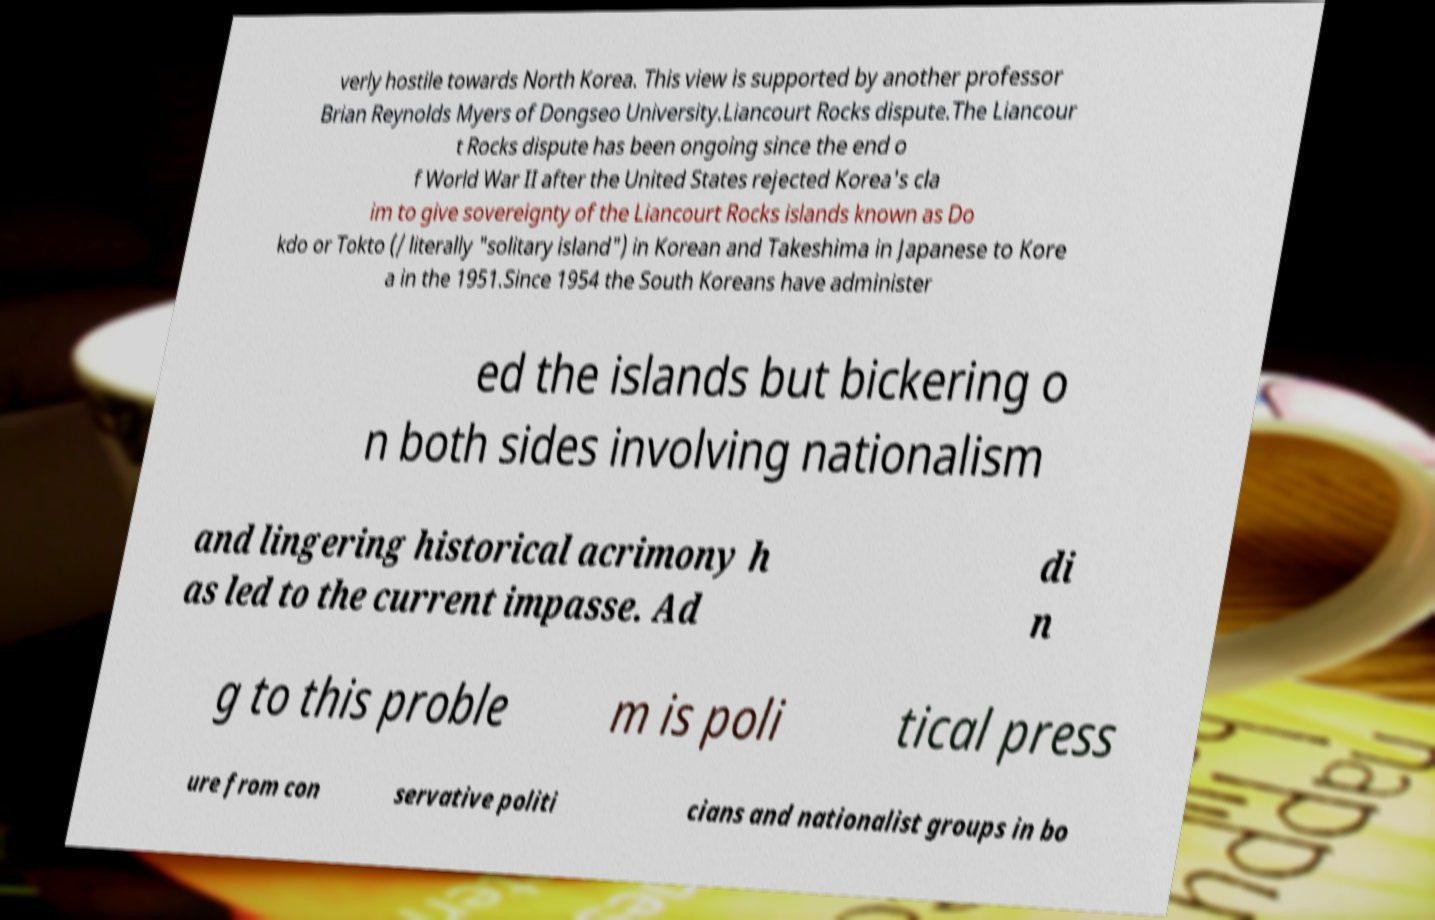Could you assist in decoding the text presented in this image and type it out clearly? verly hostile towards North Korea. This view is supported by another professor Brian Reynolds Myers of Dongseo University.Liancourt Rocks dispute.The Liancour t Rocks dispute has been ongoing since the end o f World War II after the United States rejected Korea's cla im to give sovereignty of the Liancourt Rocks islands known as Do kdo or Tokto (/ literally "solitary island") in Korean and Takeshima in Japanese to Kore a in the 1951.Since 1954 the South Koreans have administer ed the islands but bickering o n both sides involving nationalism and lingering historical acrimony h as led to the current impasse. Ad di n g to this proble m is poli tical press ure from con servative politi cians and nationalist groups in bo 